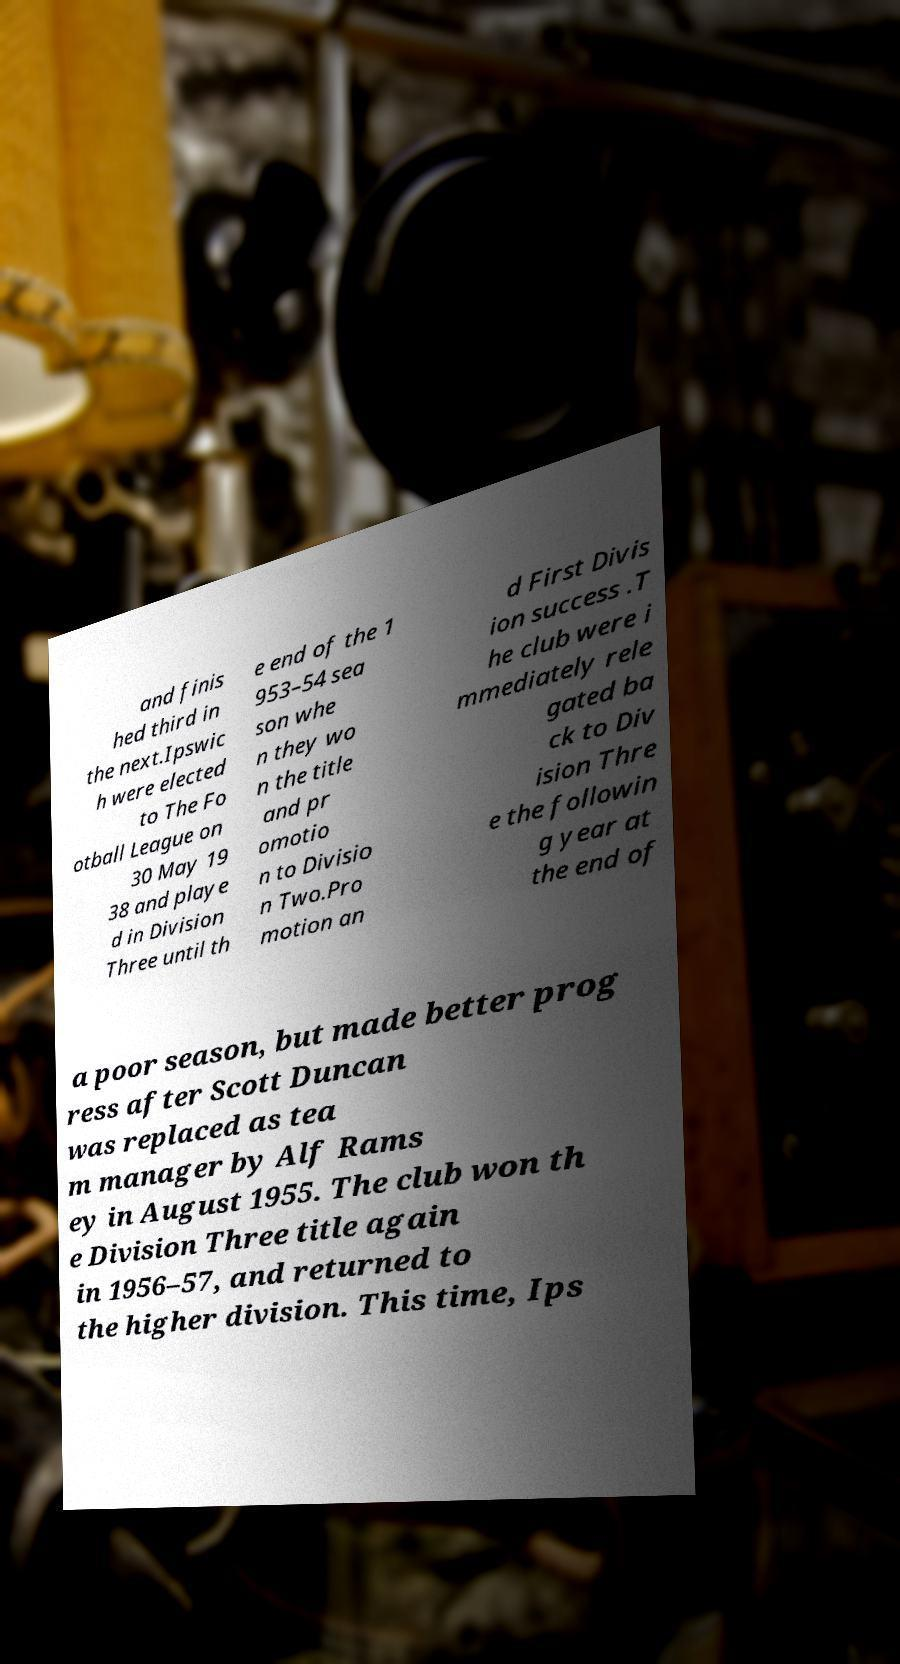Could you extract and type out the text from this image? and finis hed third in the next.Ipswic h were elected to The Fo otball League on 30 May 19 38 and playe d in Division Three until th e end of the 1 953–54 sea son whe n they wo n the title and pr omotio n to Divisio n Two.Pro motion an d First Divis ion success .T he club were i mmediately rele gated ba ck to Div ision Thre e the followin g year at the end of a poor season, but made better prog ress after Scott Duncan was replaced as tea m manager by Alf Rams ey in August 1955. The club won th e Division Three title again in 1956–57, and returned to the higher division. This time, Ips 